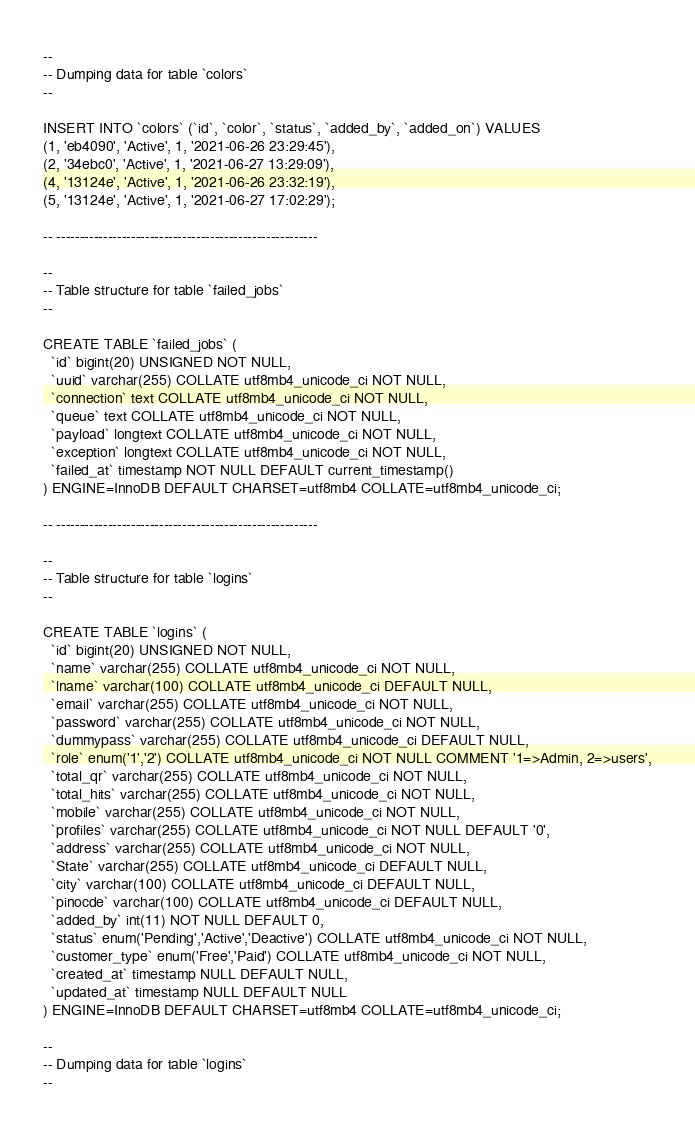Convert code to text. <code><loc_0><loc_0><loc_500><loc_500><_SQL_>
--
-- Dumping data for table `colors`
--

INSERT INTO `colors` (`id`, `color`, `status`, `added_by`, `added_on`) VALUES
(1, 'eb4090', 'Active', 1, '2021-06-26 23:29:45'),
(2, '34ebc0', 'Active', 1, '2021-06-27 13:29:09'),
(4, '13124e', 'Active', 1, '2021-06-26 23:32:19'),
(5, '13124e', 'Active', 1, '2021-06-27 17:02:29');

-- --------------------------------------------------------

--
-- Table structure for table `failed_jobs`
--

CREATE TABLE `failed_jobs` (
  `id` bigint(20) UNSIGNED NOT NULL,
  `uuid` varchar(255) COLLATE utf8mb4_unicode_ci NOT NULL,
  `connection` text COLLATE utf8mb4_unicode_ci NOT NULL,
  `queue` text COLLATE utf8mb4_unicode_ci NOT NULL,
  `payload` longtext COLLATE utf8mb4_unicode_ci NOT NULL,
  `exception` longtext COLLATE utf8mb4_unicode_ci NOT NULL,
  `failed_at` timestamp NOT NULL DEFAULT current_timestamp()
) ENGINE=InnoDB DEFAULT CHARSET=utf8mb4 COLLATE=utf8mb4_unicode_ci;

-- --------------------------------------------------------

--
-- Table structure for table `logins`
--

CREATE TABLE `logins` (
  `id` bigint(20) UNSIGNED NOT NULL,
  `name` varchar(255) COLLATE utf8mb4_unicode_ci NOT NULL,
  `lname` varchar(100) COLLATE utf8mb4_unicode_ci DEFAULT NULL,
  `email` varchar(255) COLLATE utf8mb4_unicode_ci NOT NULL,
  `password` varchar(255) COLLATE utf8mb4_unicode_ci NOT NULL,
  `dummypass` varchar(255) COLLATE utf8mb4_unicode_ci DEFAULT NULL,
  `role` enum('1','2') COLLATE utf8mb4_unicode_ci NOT NULL COMMENT '1=>Admin, 2=>users',
  `total_qr` varchar(255) COLLATE utf8mb4_unicode_ci NOT NULL,
  `total_hits` varchar(255) COLLATE utf8mb4_unicode_ci NOT NULL,
  `mobile` varchar(255) COLLATE utf8mb4_unicode_ci NOT NULL,
  `profiles` varchar(255) COLLATE utf8mb4_unicode_ci NOT NULL DEFAULT '0',
  `address` varchar(255) COLLATE utf8mb4_unicode_ci NOT NULL,
  `State` varchar(255) COLLATE utf8mb4_unicode_ci DEFAULT NULL,
  `city` varchar(100) COLLATE utf8mb4_unicode_ci DEFAULT NULL,
  `pinocde` varchar(100) COLLATE utf8mb4_unicode_ci DEFAULT NULL,
  `added_by` int(11) NOT NULL DEFAULT 0,
  `status` enum('Pending','Active','Deactive') COLLATE utf8mb4_unicode_ci NOT NULL,
  `customer_type` enum('Free','Paid') COLLATE utf8mb4_unicode_ci NOT NULL,
  `created_at` timestamp NULL DEFAULT NULL,
  `updated_at` timestamp NULL DEFAULT NULL
) ENGINE=InnoDB DEFAULT CHARSET=utf8mb4 COLLATE=utf8mb4_unicode_ci;

--
-- Dumping data for table `logins`
--
</code> 